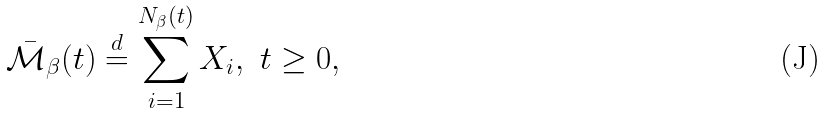<formula> <loc_0><loc_0><loc_500><loc_500>\bar { \mathcal { M } } _ { \beta } ( t ) \stackrel { d } { = } \sum _ { i = 1 } ^ { N _ { \beta } ( t ) } X _ { i } , \ t \geq 0 ,</formula> 